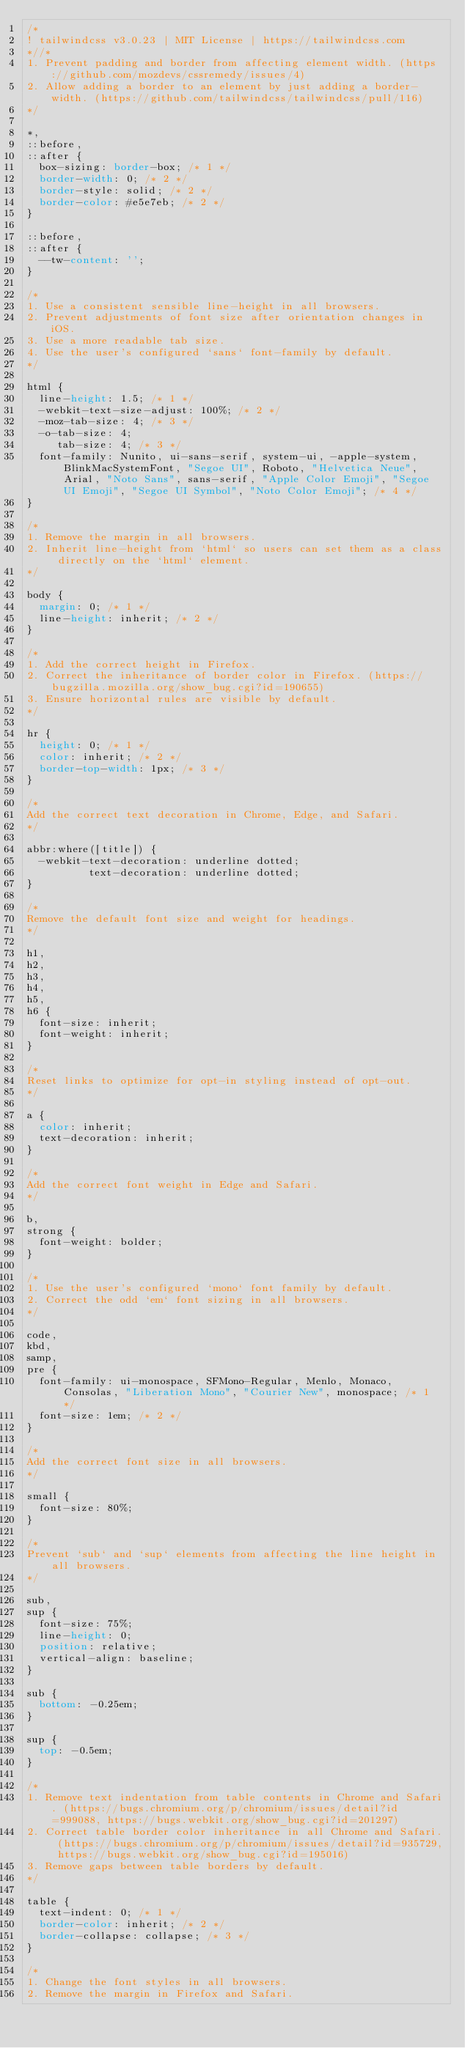Convert code to text. <code><loc_0><loc_0><loc_500><loc_500><_CSS_>/*
! tailwindcss v3.0.23 | MIT License | https://tailwindcss.com
*//*
1. Prevent padding and border from affecting element width. (https://github.com/mozdevs/cssremedy/issues/4)
2. Allow adding a border to an element by just adding a border-width. (https://github.com/tailwindcss/tailwindcss/pull/116)
*/

*,
::before,
::after {
  box-sizing: border-box; /* 1 */
  border-width: 0; /* 2 */
  border-style: solid; /* 2 */
  border-color: #e5e7eb; /* 2 */
}

::before,
::after {
  --tw-content: '';
}

/*
1. Use a consistent sensible line-height in all browsers.
2. Prevent adjustments of font size after orientation changes in iOS.
3. Use a more readable tab size.
4. Use the user's configured `sans` font-family by default.
*/

html {
  line-height: 1.5; /* 1 */
  -webkit-text-size-adjust: 100%; /* 2 */
  -moz-tab-size: 4; /* 3 */
  -o-tab-size: 4;
     tab-size: 4; /* 3 */
  font-family: Nunito, ui-sans-serif, system-ui, -apple-system, BlinkMacSystemFont, "Segoe UI", Roboto, "Helvetica Neue", Arial, "Noto Sans", sans-serif, "Apple Color Emoji", "Segoe UI Emoji", "Segoe UI Symbol", "Noto Color Emoji"; /* 4 */
}

/*
1. Remove the margin in all browsers.
2. Inherit line-height from `html` so users can set them as a class directly on the `html` element.
*/

body {
  margin: 0; /* 1 */
  line-height: inherit; /* 2 */
}

/*
1. Add the correct height in Firefox.
2. Correct the inheritance of border color in Firefox. (https://bugzilla.mozilla.org/show_bug.cgi?id=190655)
3. Ensure horizontal rules are visible by default.
*/

hr {
  height: 0; /* 1 */
  color: inherit; /* 2 */
  border-top-width: 1px; /* 3 */
}

/*
Add the correct text decoration in Chrome, Edge, and Safari.
*/

abbr:where([title]) {
  -webkit-text-decoration: underline dotted;
          text-decoration: underline dotted;
}

/*
Remove the default font size and weight for headings.
*/

h1,
h2,
h3,
h4,
h5,
h6 {
  font-size: inherit;
  font-weight: inherit;
}

/*
Reset links to optimize for opt-in styling instead of opt-out.
*/

a {
  color: inherit;
  text-decoration: inherit;
}

/*
Add the correct font weight in Edge and Safari.
*/

b,
strong {
  font-weight: bolder;
}

/*
1. Use the user's configured `mono` font family by default.
2. Correct the odd `em` font sizing in all browsers.
*/

code,
kbd,
samp,
pre {
  font-family: ui-monospace, SFMono-Regular, Menlo, Monaco, Consolas, "Liberation Mono", "Courier New", monospace; /* 1 */
  font-size: 1em; /* 2 */
}

/*
Add the correct font size in all browsers.
*/

small {
  font-size: 80%;
}

/*
Prevent `sub` and `sup` elements from affecting the line height in all browsers.
*/

sub,
sup {
  font-size: 75%;
  line-height: 0;
  position: relative;
  vertical-align: baseline;
}

sub {
  bottom: -0.25em;
}

sup {
  top: -0.5em;
}

/*
1. Remove text indentation from table contents in Chrome and Safari. (https://bugs.chromium.org/p/chromium/issues/detail?id=999088, https://bugs.webkit.org/show_bug.cgi?id=201297)
2. Correct table border color inheritance in all Chrome and Safari. (https://bugs.chromium.org/p/chromium/issues/detail?id=935729, https://bugs.webkit.org/show_bug.cgi?id=195016)
3. Remove gaps between table borders by default.
*/

table {
  text-indent: 0; /* 1 */
  border-color: inherit; /* 2 */
  border-collapse: collapse; /* 3 */
}

/*
1. Change the font styles in all browsers.
2. Remove the margin in Firefox and Safari.</code> 